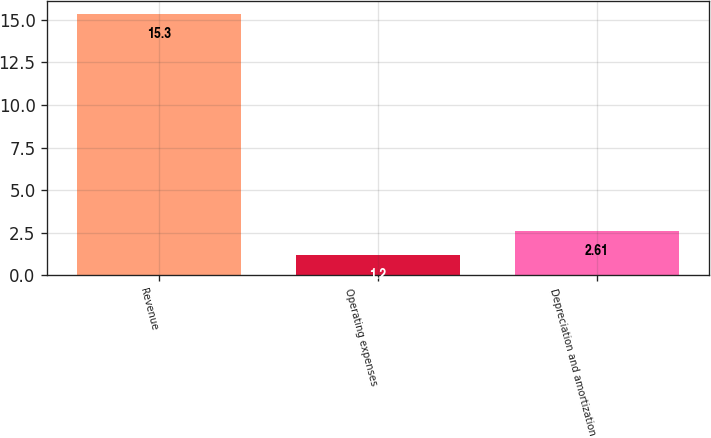Convert chart. <chart><loc_0><loc_0><loc_500><loc_500><bar_chart><fcel>Revenue<fcel>Operating expenses<fcel>Depreciation and amortization<nl><fcel>15.3<fcel>1.2<fcel>2.61<nl></chart> 